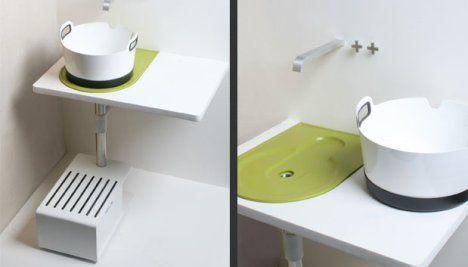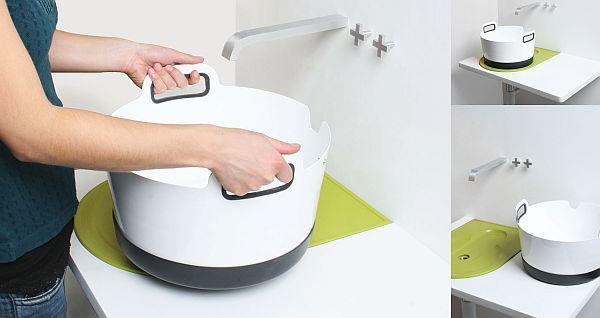The first image is the image on the left, the second image is the image on the right. Evaluate the accuracy of this statement regarding the images: "A sink cabinet stands flush against a wall and has two full-length front panel doors that open at the center, with black handles at upper center,". Is it true? Answer yes or no. No. The first image is the image on the left, the second image is the image on the right. Assess this claim about the two images: "A sink unit has a rectangular double-door cabinet underneath at least one rectangular inset sink.". Correct or not? Answer yes or no. No. 